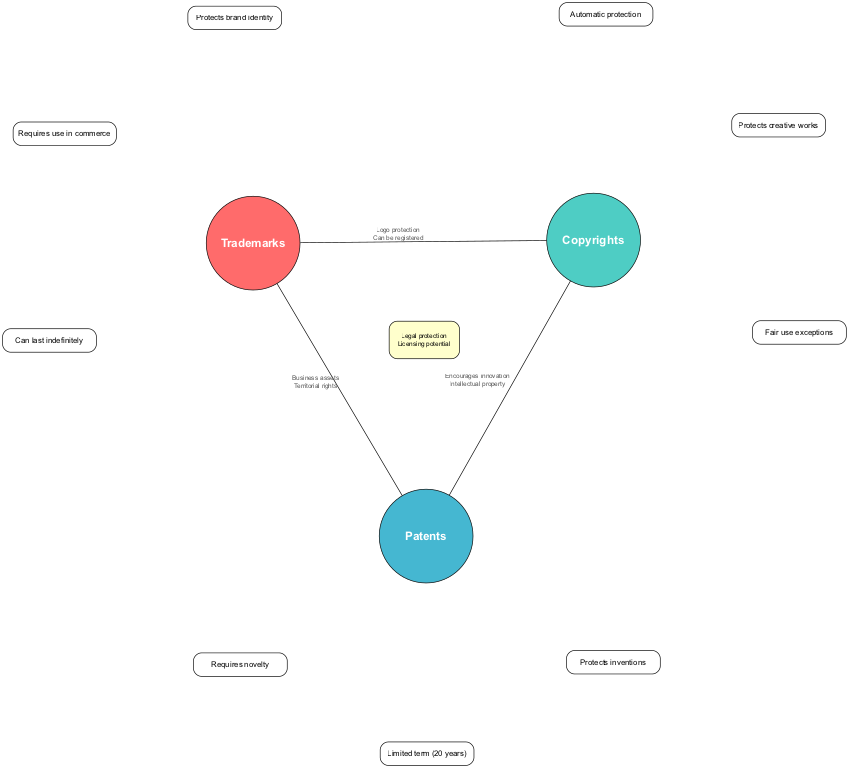What is a unique aspect of trademarks? The diagram lists three unique aspects for trademarks, one of which is protecting brand identity, which is clearly indicated in the trademarks circle.
Answer: Protects brand identity How many unique aspects does copyrights have? By looking at the copyrights circle, we see three unique aspects listed, confirming that there are a total of three unique aspects visible for copyrights.
Answer: 3 What do trademarks and copyrights have in common? The overlapping area between trademarks and copyrights displays two aspects, one of which is logo protection, indicating that these two have a common aspect shown in their intersection.
Answer: Logo protection What is the duration of patent protection? In the patents circle, it states that patent protection has a limited term of 20 years, making it explicit in the diagram regarding the duration of patent protection.
Answer: 20 years Which aspects overlap among trademarks, copyrights, and patents? The intersection where all three circles meet lists two aspects: legal protection and licensing potential, which are shared among all three types of intellectual property.
Answer: Legal protection, Licensing potential What do copyrights and patents share in common? The overlapping area between copyrights and patents outlines two aspects, one of which is encouraging innovation, marking a shared characteristic in their intersection.
Answer: Encourages innovation How many overlapping areas are there between trademarks and patents? The diagram shows one overlapping area specifically between trademarks and patents, capturing their shared aspects, indicating that there is exactly one such area present.
Answer: 1 Which circle has a unique aspect that requires novelty? In viewing the diagram, the patents circle distinctly mentions that it requires novelty, identifying it as a unique aspect relevant only to patents.
Answer: Patents What are the business assets associated with trademarks and patents? Within the overlapping area between trademarks and patents, one of the shared aspects is listed as business assets, demonstrating a commonality in terms of their nature and value.
Answer: Business assets 